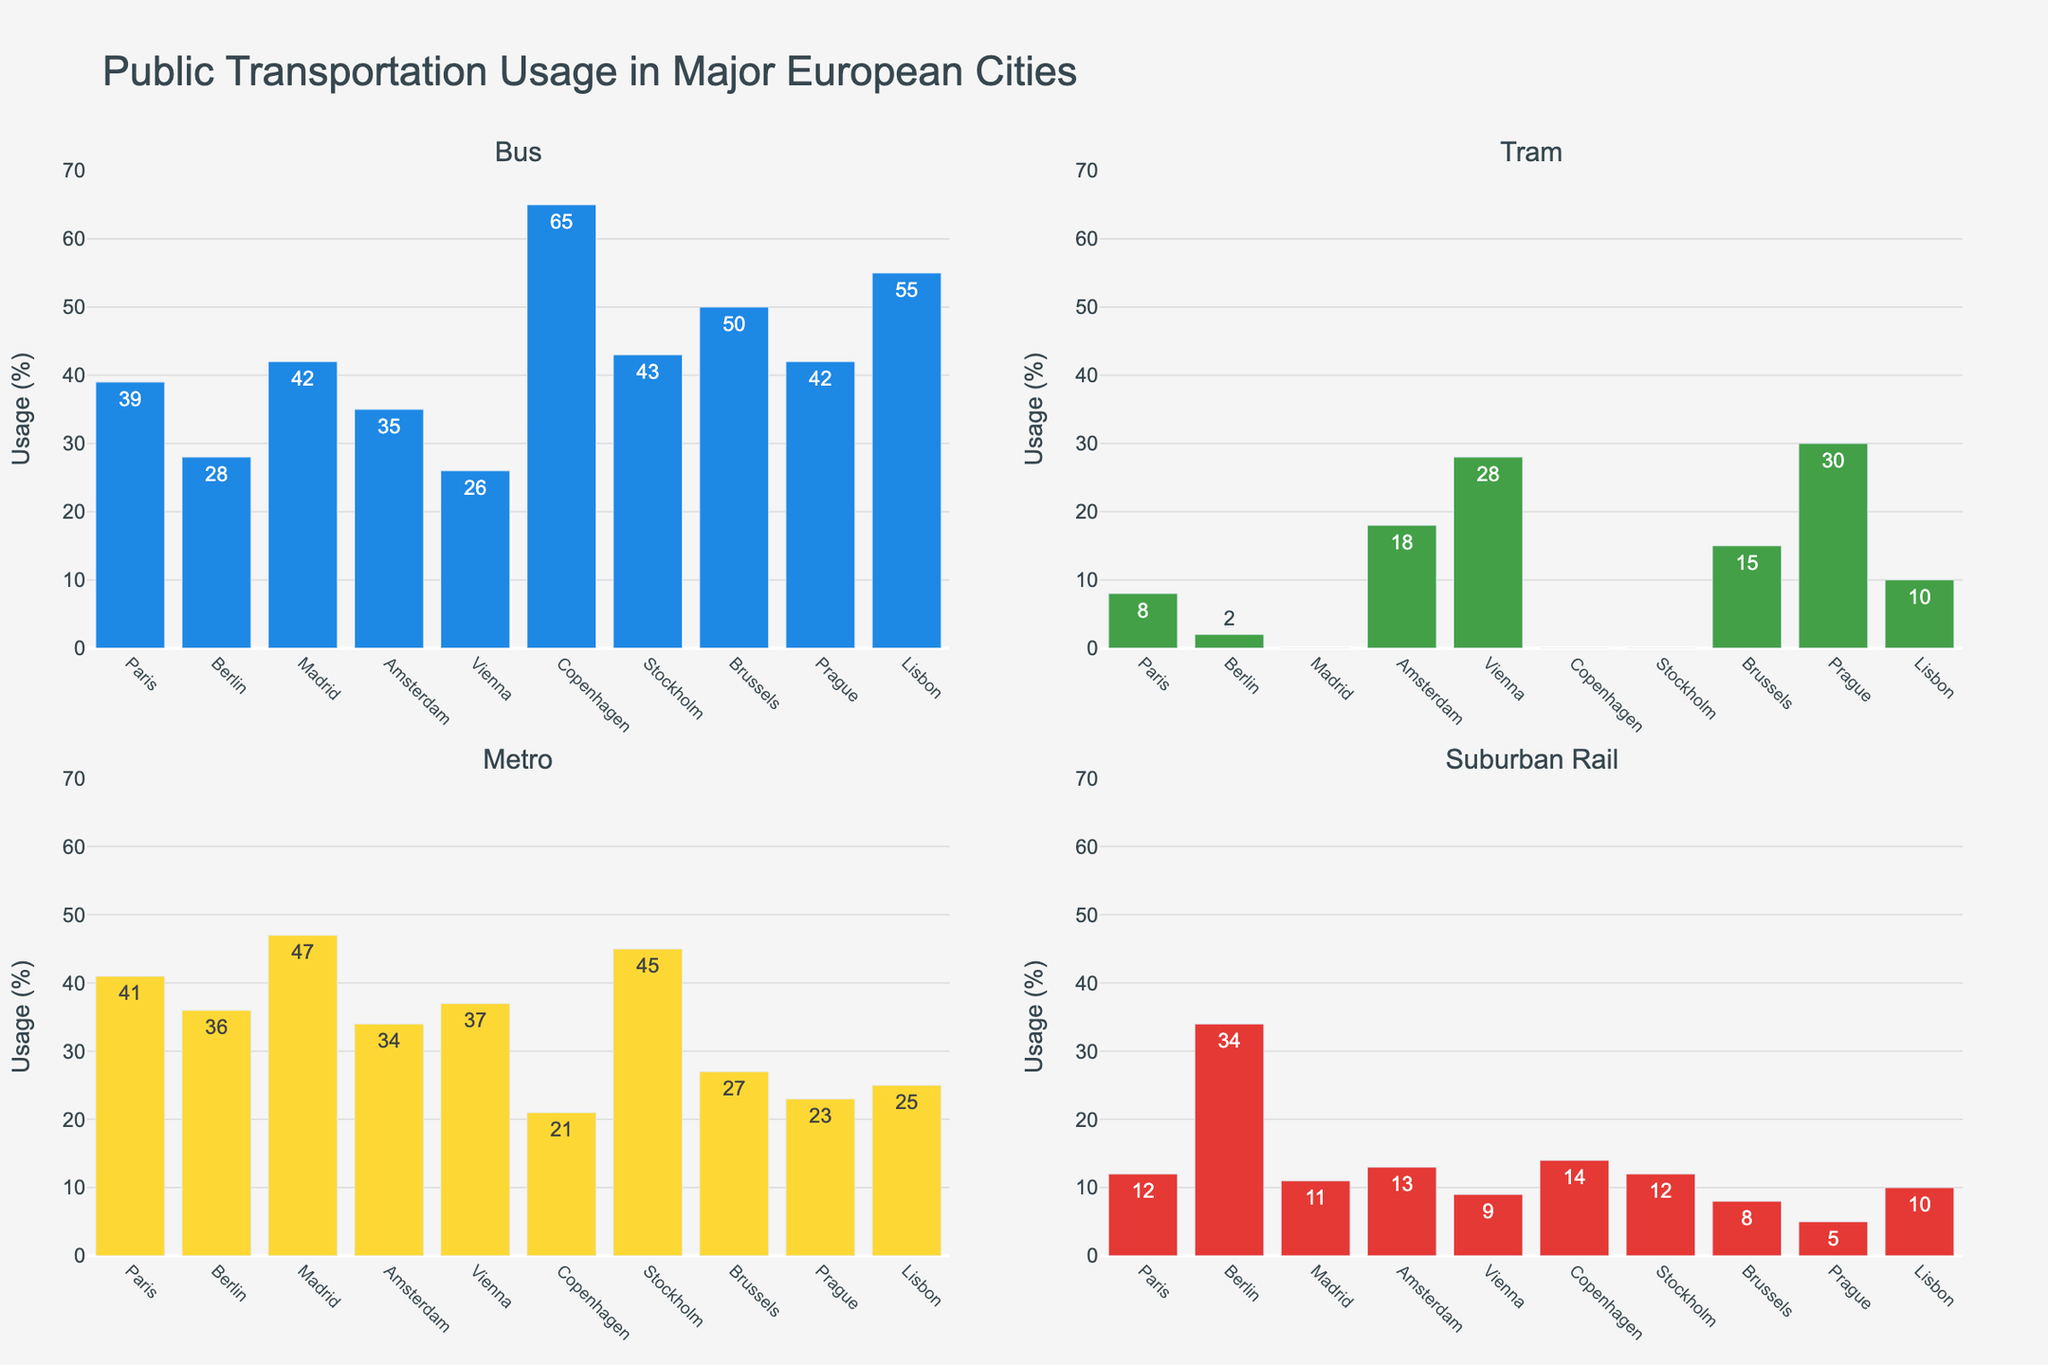What's the title of the figure? The title is usually displayed at the top of the figure. In this case, it reads "Public Transportation Usage in Major European Cities".
Answer: Public Transportation Usage in Major European Cities Which city has the highest bus usage? Look at the bar chart for "Bus" and identify the tallest bar. The city label for this bar is Copenhagen.
Answer: Copenhagen What is the total percentage of public transportation usage for the Metro mode in Paris and Madrid combined? Find the values for Metro in Paris (41) and Madrid (47) and add them together (41 + 47 = 88).
Answer: 88 How does tram usage in Amsterdam compare to Prague? Compare the heights of the bars for Tram in Amsterdam and Prague. Amsterdam has a usage of 18, while Prague has a usage of 30, indicating that Prague has a higher tram usage.
Answer: Prague has a higher tram usage than Amsterdam Which transportation mode has the lowest average usage across all cities? Calculate the average usage of each mode across all cities. For Bus, the average is (39+28+42+35+26+65+43+50+42+55)/10 = 42.5; for Tram, (8+2+0+18+28+0+0+15+30+10)/10 = 11.1; for Metro, (41+36+47+34+37+21+45+27+23+25)/10 = 33.5; for Suburban Rail, (12+34+11+13+9+14+12+8+5+10)/10 = 13.8. Tram has the lowest average usage.
Answer: Tram Which city has a significantly higher suburban rail usage compared to others? Look for the bar in the "Suburban Rail" subplot that is much taller than the others. Berlin has the highest suburban rail usage at 34%.
Answer: Berlin What is the difference in metro usage between Stockholm and Vienna? Find the values for Metro in Stockholm (45) and Vienna (37) and calculate the difference (45 - 37 = 8).
Answer: 8 In terms of bus usage, which cities fall below the average bus usage across all cities? Calculate the average bus usage ((39+28+42+35+26+65+43+50+42+55)/10 = 42.5) and identify cities below this value: Berlin (28), Vienna (26).
Answer: Berlin, Vienna What patterns can we observe in terms of tram usage across multiple cities? Summarize any noticeable trends: Only a few cities have significant tram usage, notably Amsterdam, Vienna, Brussels, and Prague. Many cities show very low or no tram usage.
Answer: Few cities have significant tram usage; mostly low or none Which city has the most balanced usage distribution across all four modes of transportation? Identify the city where the bars for Bus, Tram, Metro, and Suburban Rail are relatively close in height: Vienna has a more evenly distributed usage across the transportation modes.
Answer: Vienna 